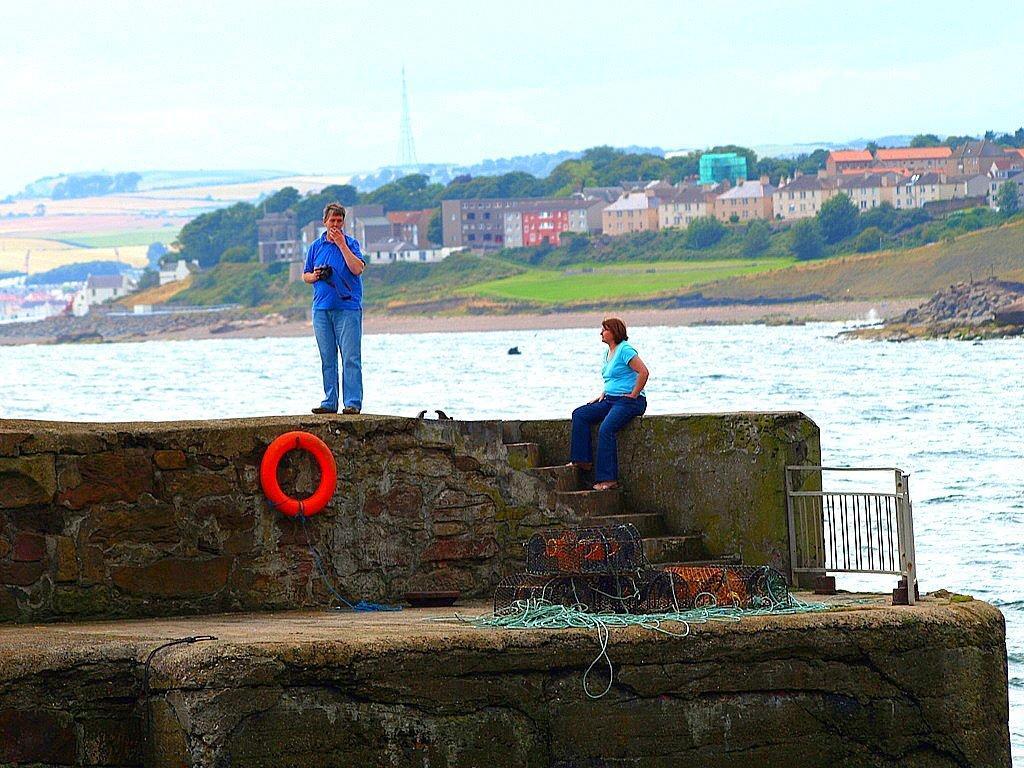Could you give a brief overview of what you see in this image? In this image there is the sky towards the top of the image, there are buildings, there is grass, there are trees, there is water, there is a wall towards the bottom of the image, there are objects on the ground, there is a woman sitting on the wall, there is staircase, there is a man standing and holding an object. 